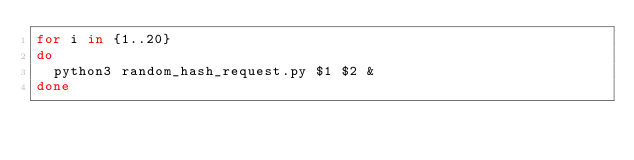<code> <loc_0><loc_0><loc_500><loc_500><_Bash_>for i in {1..20}
do
	python3 random_hash_request.py $1 $2 &
done
</code> 